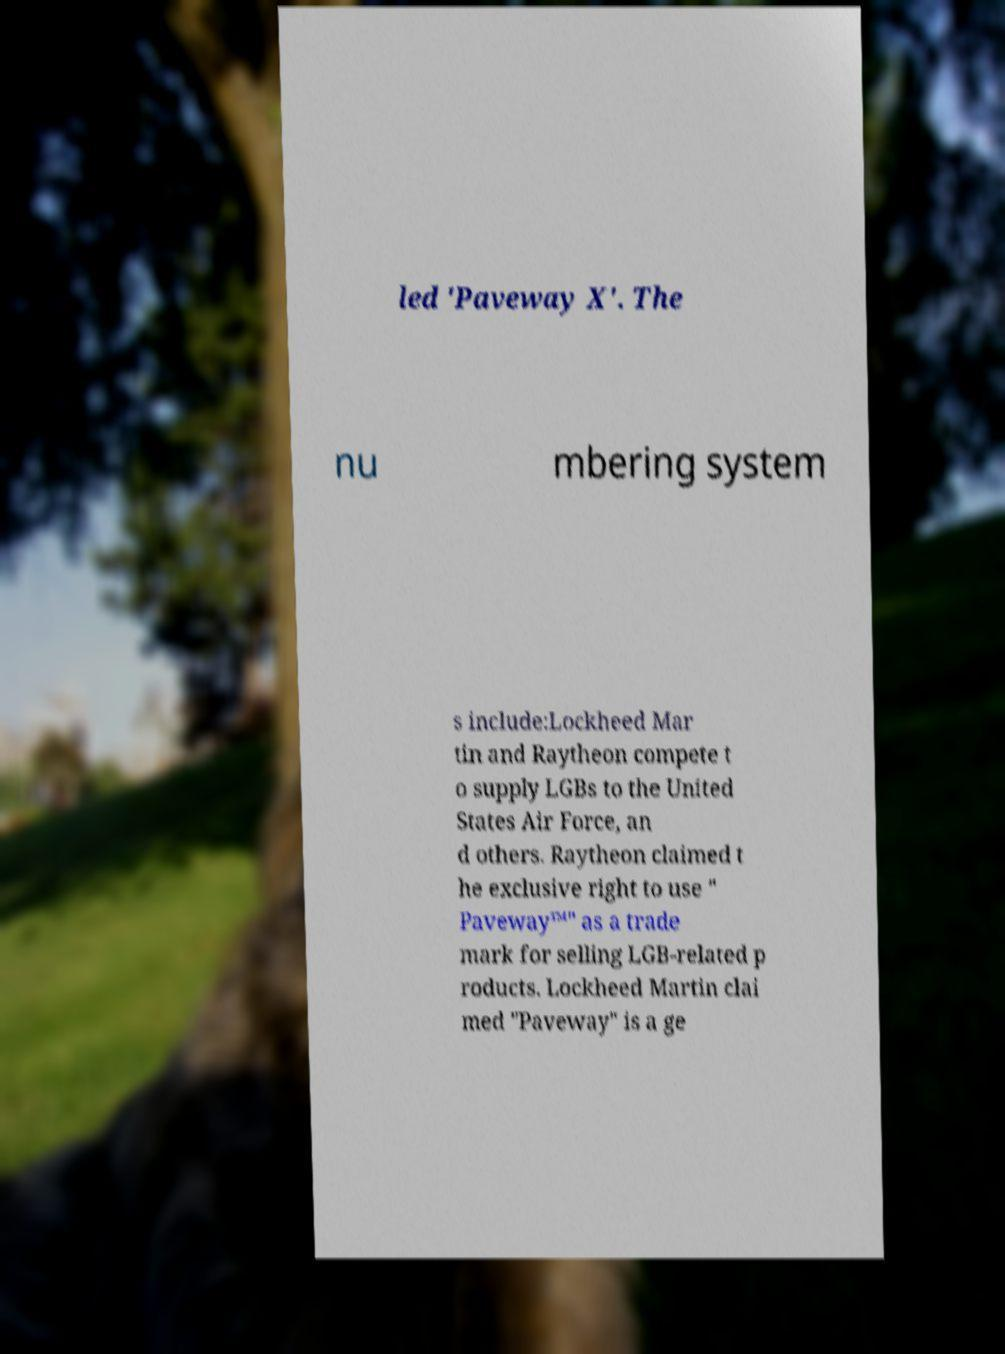Could you assist in decoding the text presented in this image and type it out clearly? led 'Paveway X'. The nu mbering system s include:Lockheed Mar tin and Raytheon compete t o supply LGBs to the United States Air Force, an d others. Raytheon claimed t he exclusive right to use " Paveway™" as a trade mark for selling LGB-related p roducts. Lockheed Martin clai med "Paveway" is a ge 